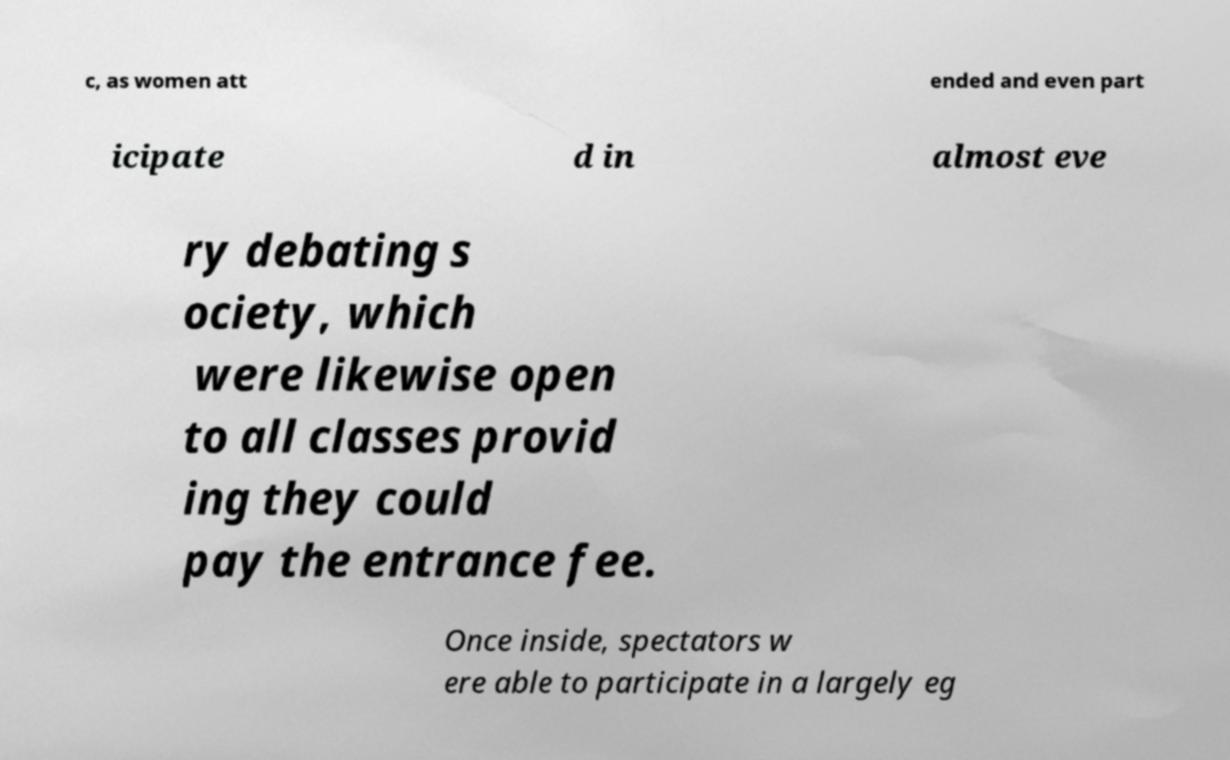Please read and relay the text visible in this image. What does it say? c, as women att ended and even part icipate d in almost eve ry debating s ociety, which were likewise open to all classes provid ing they could pay the entrance fee. Once inside, spectators w ere able to participate in a largely eg 